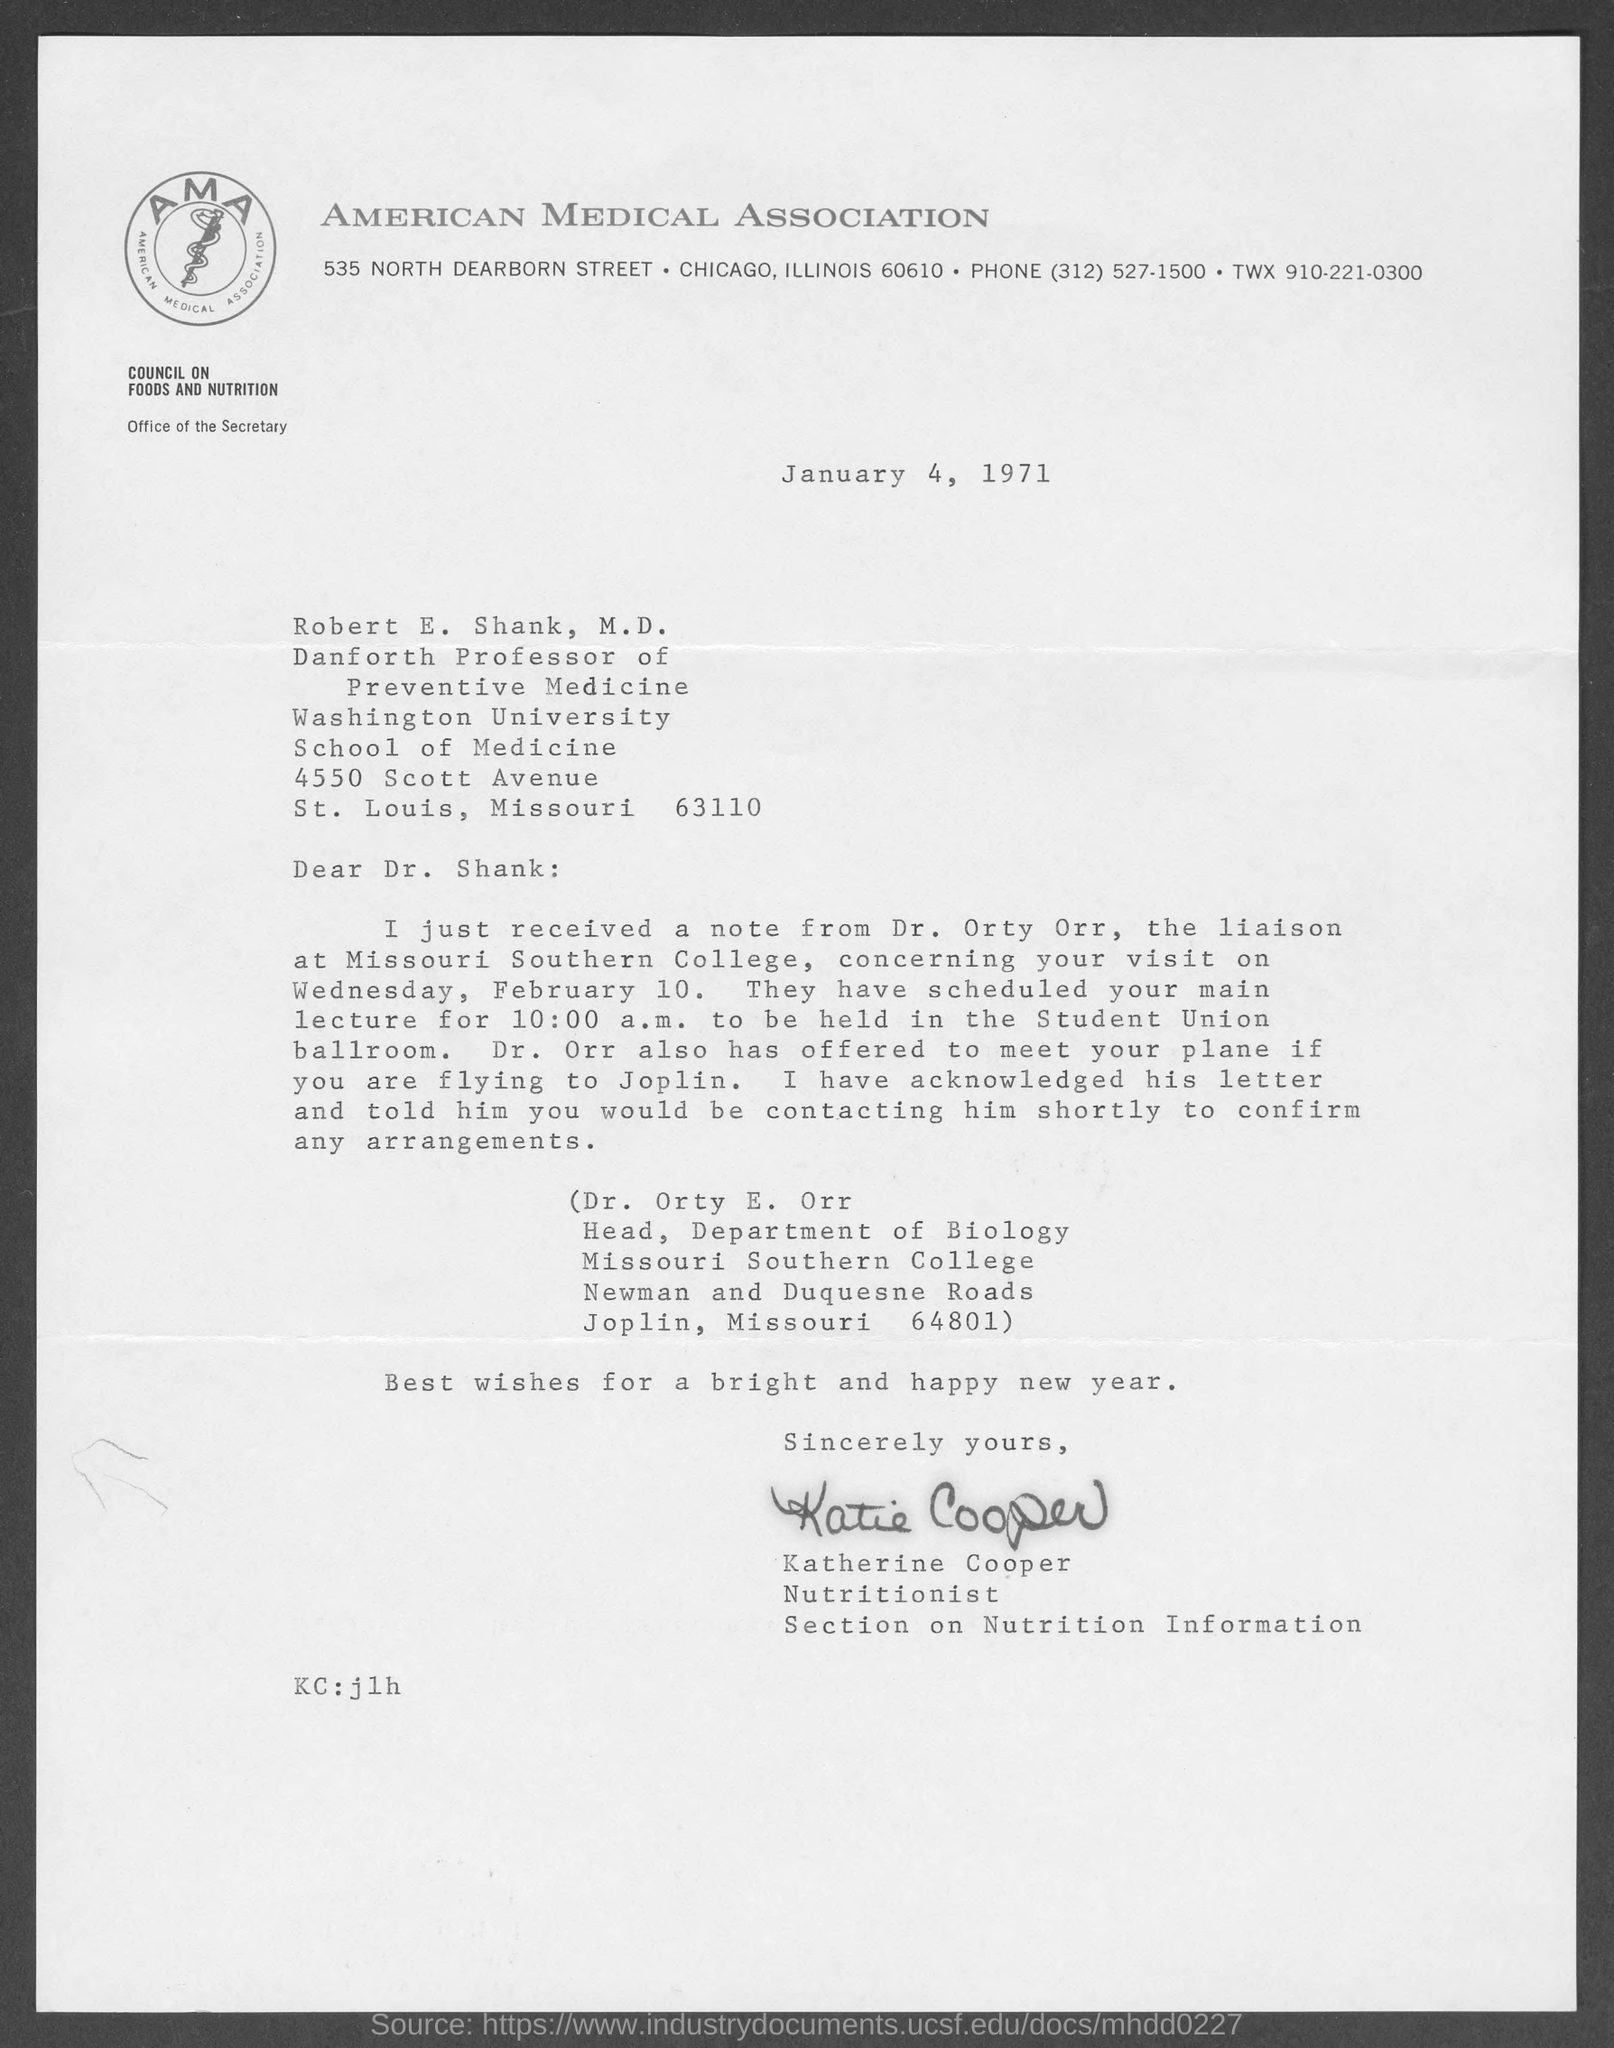What is the date mentioned ?
Provide a succinct answer. January 4 , 1971. This letter is written by whom ?
Your response must be concise. KATHERINE COOPER. In which state and city  American Medical Association located ?
Give a very brief answer. CHICAGO, ILLINOIS. 